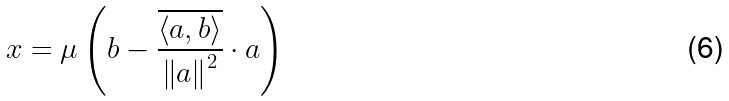<formula> <loc_0><loc_0><loc_500><loc_500>x = \mu \left ( b - \frac { \overline { \left \langle a , b \right \rangle } } { \left \| a \right \| ^ { 2 } } \cdot a \right )</formula> 